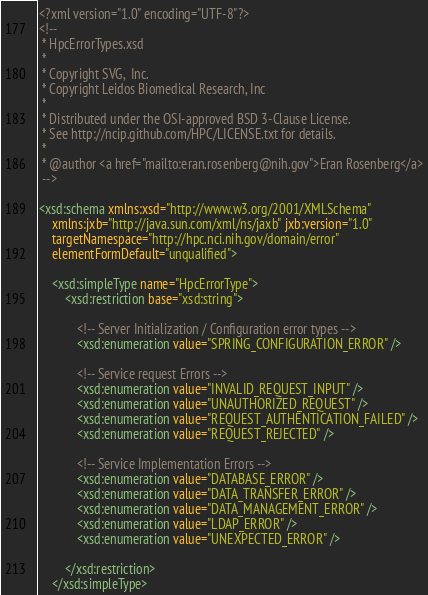Convert code to text. <code><loc_0><loc_0><loc_500><loc_500><_XML_><?xml version="1.0" encoding="UTF-8"?>
<!--  
 * HpcErrorTypes.xsd
 *
 * Copyright SVG,  Inc.
 * Copyright Leidos Biomedical Research, Inc
 * 
 * Distributed under the OSI-approved BSD 3-Clause License.
 * See http://ncip.github.com/HPC/LICENSE.txt for details.
 *
 * @author <a href="mailto:eran.rosenberg@nih.gov">Eran Rosenberg</a>
 -->

<xsd:schema xmlns:xsd="http://www.w3.org/2001/XMLSchema"
	xmlns:jxb="http://java.sun.com/xml/ns/jaxb" jxb:version="1.0"
	targetNamespace="http://hpc.nci.nih.gov/domain/error"
	elementFormDefault="unqualified">

	<xsd:simpleType name="HpcErrorType">
		<xsd:restriction base="xsd:string">

			<!-- Server Initialization / Configuration error types -->
			<xsd:enumeration value="SPRING_CONFIGURATION_ERROR" />

			<!-- Service request Errors -->
			<xsd:enumeration value="INVALID_REQUEST_INPUT" />
			<xsd:enumeration value="UNAUTHORIZED_REQUEST" />
			<xsd:enumeration value="REQUEST_AUTHENTICATION_FAILED" />
			<xsd:enumeration value="REQUEST_REJECTED" />

			<!-- Service Implementation Errors -->
			<xsd:enumeration value="DATABASE_ERROR" />
			<xsd:enumeration value="DATA_TRANSFER_ERROR" />
			<xsd:enumeration value="DATA_MANAGEMENT_ERROR" />
			<xsd:enumeration value="LDAP_ERROR" />
			<xsd:enumeration value="UNEXPECTED_ERROR" />

		</xsd:restriction>
	</xsd:simpleType>
</code> 